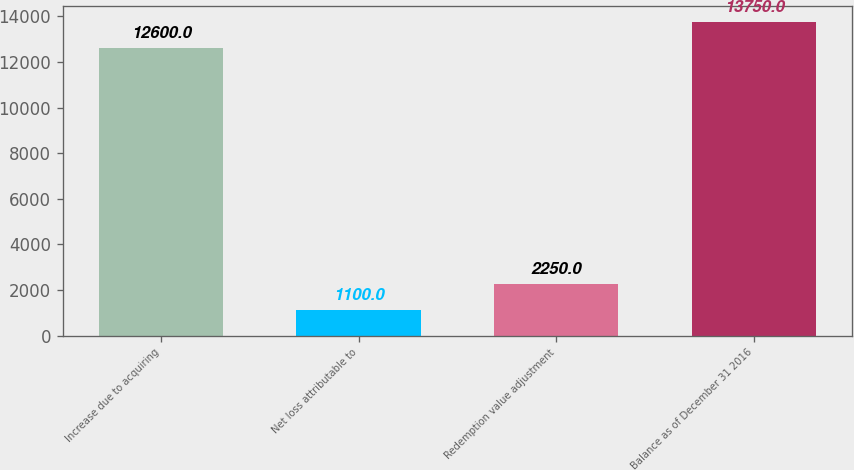<chart> <loc_0><loc_0><loc_500><loc_500><bar_chart><fcel>Increase due to acquiring<fcel>Net loss attributable to<fcel>Redemption value adjustment<fcel>Balance as of December 31 2016<nl><fcel>12600<fcel>1100<fcel>2250<fcel>13750<nl></chart> 